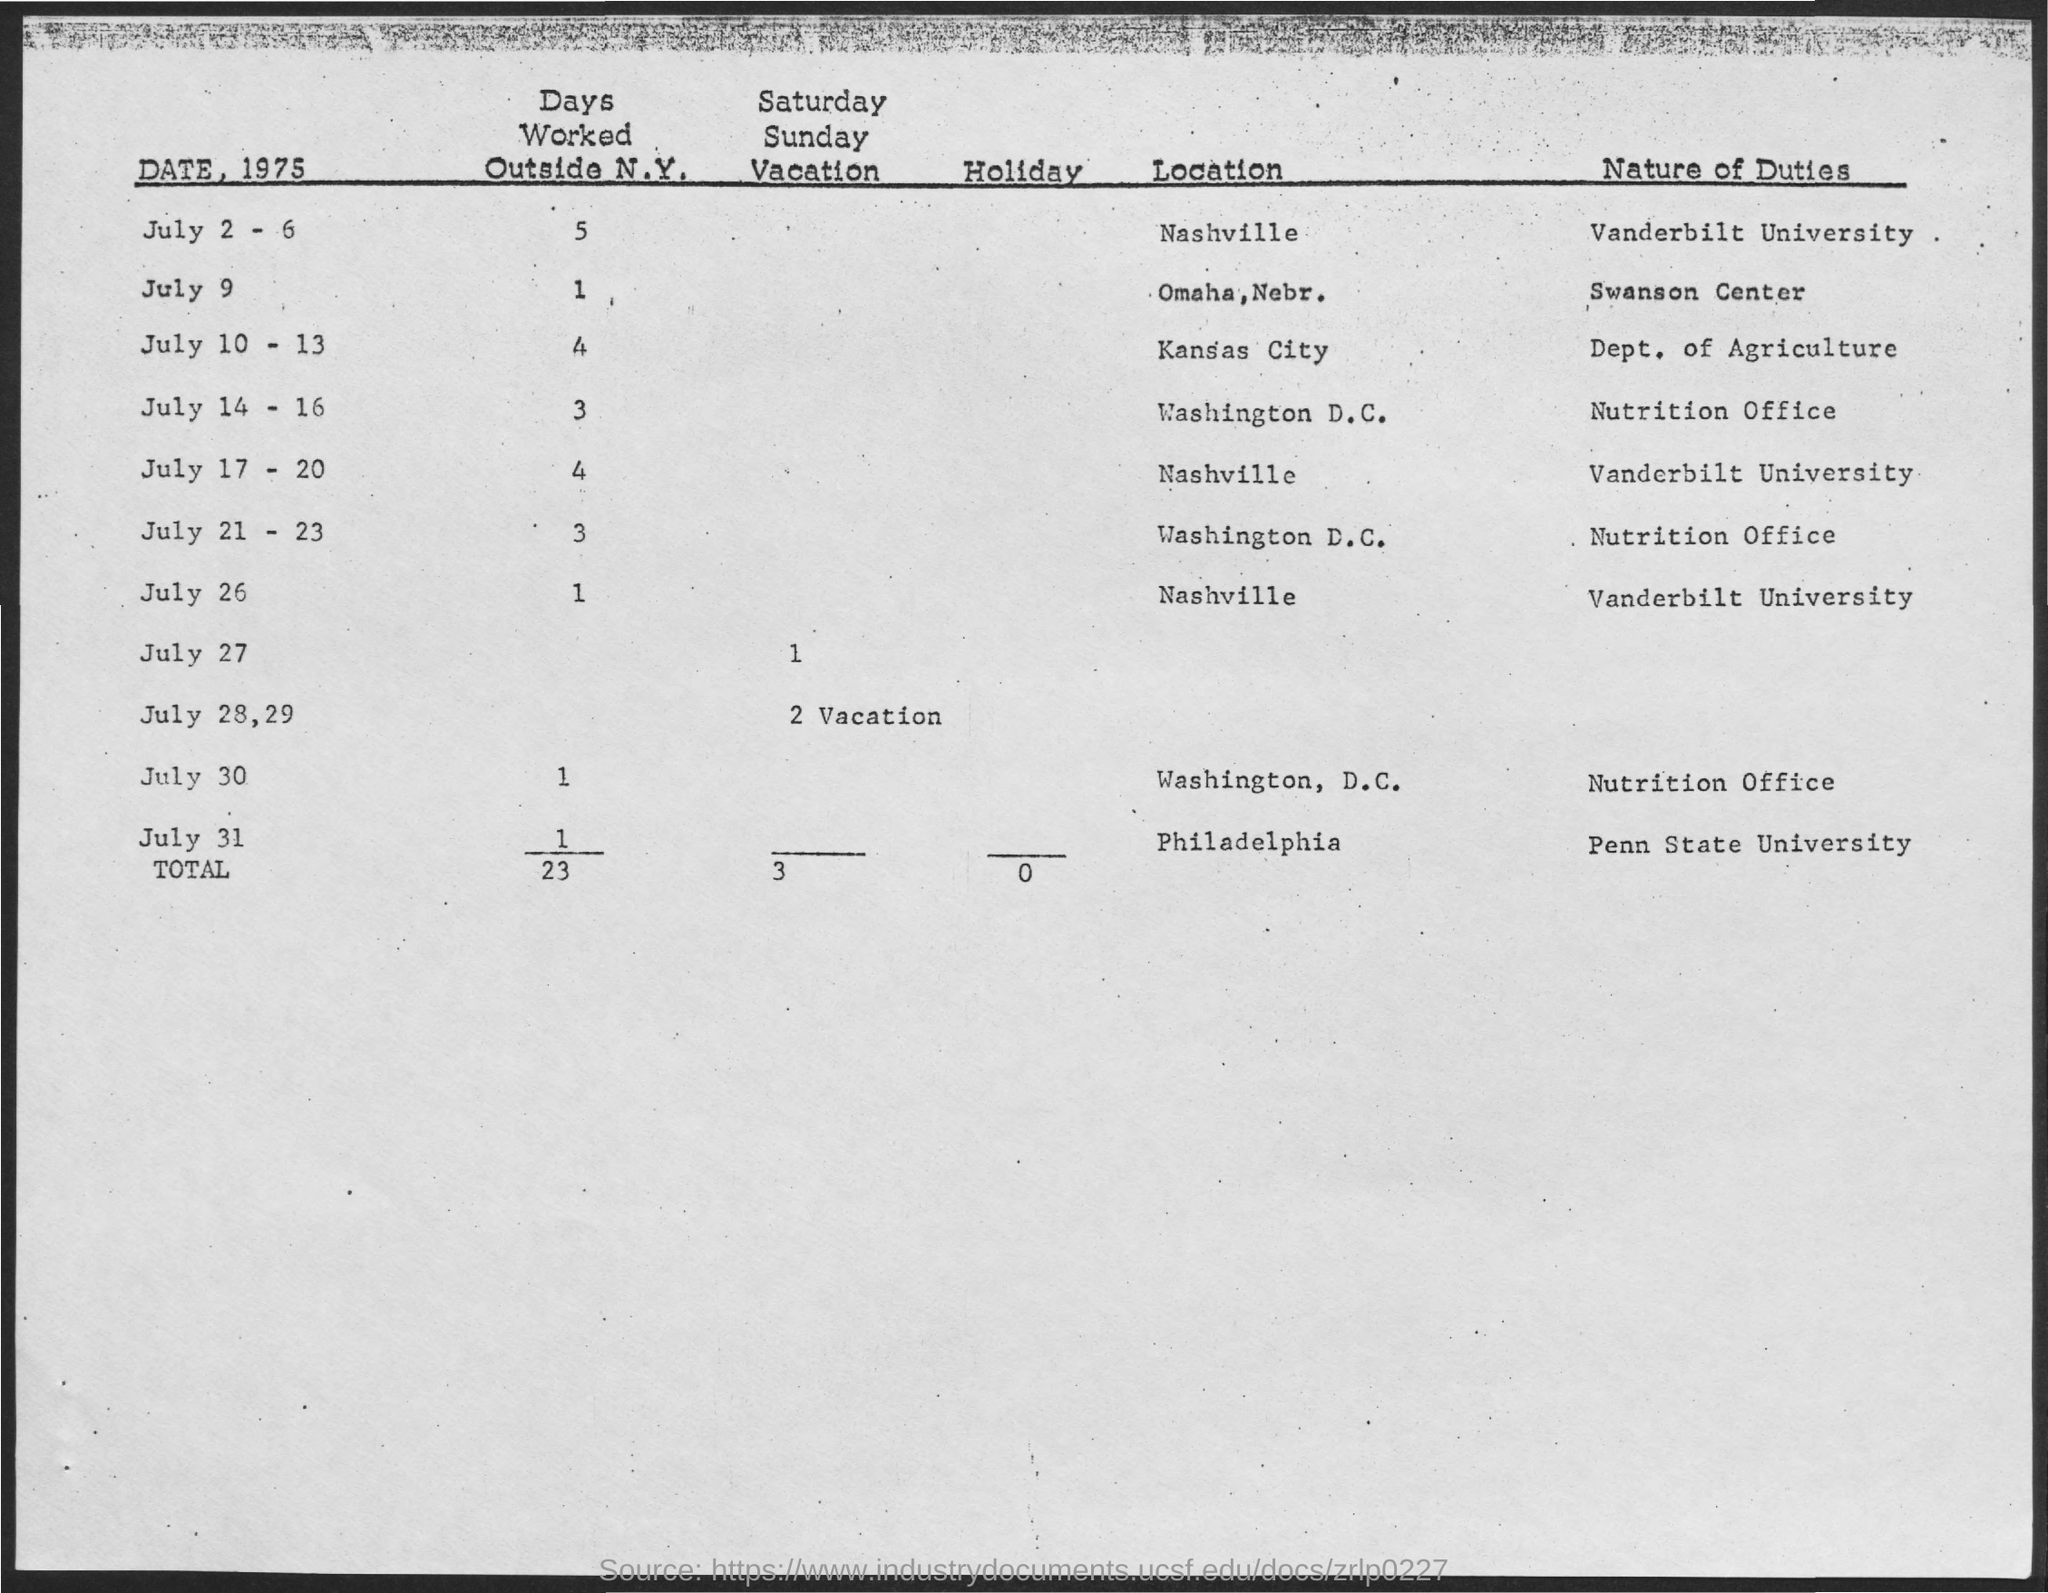Highlight a few significant elements in this photo. On July 31st, the nature of duty is present at Penn State University. On July 30, the nature of duty at the Nutrition Office is unknown. The total number of Saturday and Sunday vacations is three. On July 26, Nashville is located where? On July 9th, the nature of duty at the Swanson Center is... 